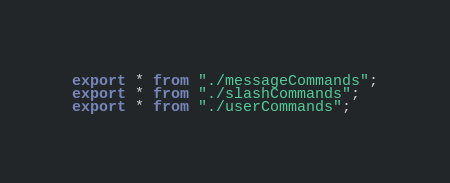<code> <loc_0><loc_0><loc_500><loc_500><_TypeScript_>export * from "./messageCommands";
export * from "./slashCommands";
export * from "./userCommands";
</code> 